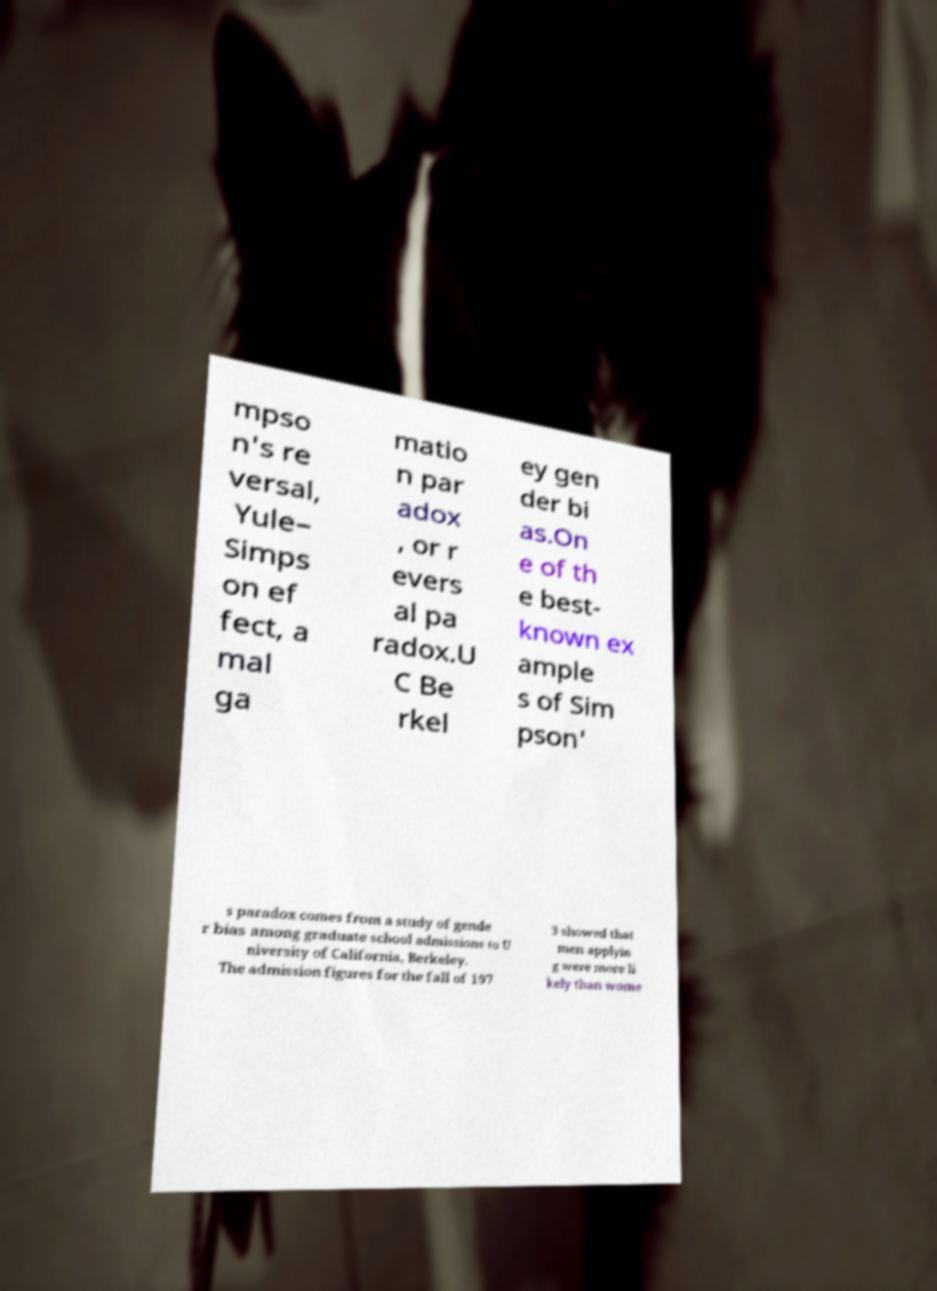Can you accurately transcribe the text from the provided image for me? mpso n's re versal, Yule– Simps on ef fect, a mal ga matio n par adox , or r evers al pa radox.U C Be rkel ey gen der bi as.On e of th e best- known ex ample s of Sim pson' s paradox comes from a study of gende r bias among graduate school admissions to U niversity of California, Berkeley. The admission figures for the fall of 197 3 showed that men applyin g were more li kely than wome 